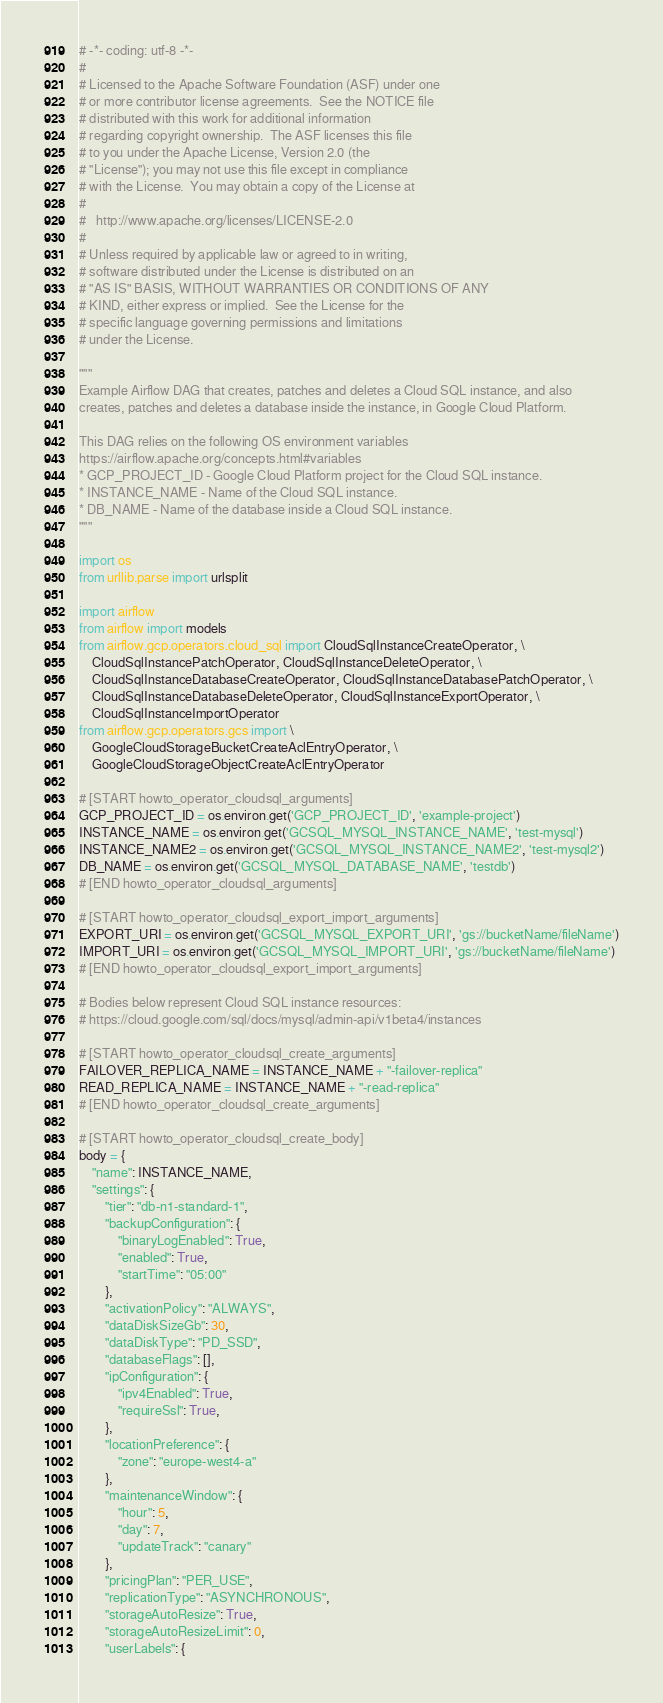Convert code to text. <code><loc_0><loc_0><loc_500><loc_500><_Python_># -*- coding: utf-8 -*-
#
# Licensed to the Apache Software Foundation (ASF) under one
# or more contributor license agreements.  See the NOTICE file
# distributed with this work for additional information
# regarding copyright ownership.  The ASF licenses this file
# to you under the Apache License, Version 2.0 (the
# "License"); you may not use this file except in compliance
# with the License.  You may obtain a copy of the License at
#
#   http://www.apache.org/licenses/LICENSE-2.0
#
# Unless required by applicable law or agreed to in writing,
# software distributed under the License is distributed on an
# "AS IS" BASIS, WITHOUT WARRANTIES OR CONDITIONS OF ANY
# KIND, either express or implied.  See the License for the
# specific language governing permissions and limitations
# under the License.

"""
Example Airflow DAG that creates, patches and deletes a Cloud SQL instance, and also
creates, patches and deletes a database inside the instance, in Google Cloud Platform.

This DAG relies on the following OS environment variables
https://airflow.apache.org/concepts.html#variables
* GCP_PROJECT_ID - Google Cloud Platform project for the Cloud SQL instance.
* INSTANCE_NAME - Name of the Cloud SQL instance.
* DB_NAME - Name of the database inside a Cloud SQL instance.
"""

import os
from urllib.parse import urlsplit

import airflow
from airflow import models
from airflow.gcp.operators.cloud_sql import CloudSqlInstanceCreateOperator, \
    CloudSqlInstancePatchOperator, CloudSqlInstanceDeleteOperator, \
    CloudSqlInstanceDatabaseCreateOperator, CloudSqlInstanceDatabasePatchOperator, \
    CloudSqlInstanceDatabaseDeleteOperator, CloudSqlInstanceExportOperator, \
    CloudSqlInstanceImportOperator
from airflow.gcp.operators.gcs import \
    GoogleCloudStorageBucketCreateAclEntryOperator, \
    GoogleCloudStorageObjectCreateAclEntryOperator

# [START howto_operator_cloudsql_arguments]
GCP_PROJECT_ID = os.environ.get('GCP_PROJECT_ID', 'example-project')
INSTANCE_NAME = os.environ.get('GCSQL_MYSQL_INSTANCE_NAME', 'test-mysql')
INSTANCE_NAME2 = os.environ.get('GCSQL_MYSQL_INSTANCE_NAME2', 'test-mysql2')
DB_NAME = os.environ.get('GCSQL_MYSQL_DATABASE_NAME', 'testdb')
# [END howto_operator_cloudsql_arguments]

# [START howto_operator_cloudsql_export_import_arguments]
EXPORT_URI = os.environ.get('GCSQL_MYSQL_EXPORT_URI', 'gs://bucketName/fileName')
IMPORT_URI = os.environ.get('GCSQL_MYSQL_IMPORT_URI', 'gs://bucketName/fileName')
# [END howto_operator_cloudsql_export_import_arguments]

# Bodies below represent Cloud SQL instance resources:
# https://cloud.google.com/sql/docs/mysql/admin-api/v1beta4/instances

# [START howto_operator_cloudsql_create_arguments]
FAILOVER_REPLICA_NAME = INSTANCE_NAME + "-failover-replica"
READ_REPLICA_NAME = INSTANCE_NAME + "-read-replica"
# [END howto_operator_cloudsql_create_arguments]

# [START howto_operator_cloudsql_create_body]
body = {
    "name": INSTANCE_NAME,
    "settings": {
        "tier": "db-n1-standard-1",
        "backupConfiguration": {
            "binaryLogEnabled": True,
            "enabled": True,
            "startTime": "05:00"
        },
        "activationPolicy": "ALWAYS",
        "dataDiskSizeGb": 30,
        "dataDiskType": "PD_SSD",
        "databaseFlags": [],
        "ipConfiguration": {
            "ipv4Enabled": True,
            "requireSsl": True,
        },
        "locationPreference": {
            "zone": "europe-west4-a"
        },
        "maintenanceWindow": {
            "hour": 5,
            "day": 7,
            "updateTrack": "canary"
        },
        "pricingPlan": "PER_USE",
        "replicationType": "ASYNCHRONOUS",
        "storageAutoResize": True,
        "storageAutoResizeLimit": 0,
        "userLabels": {</code> 